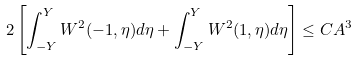<formula> <loc_0><loc_0><loc_500><loc_500>2 \left [ \int _ { - Y } ^ { Y } W ^ { 2 } ( - 1 , \eta ) d \eta + \int _ { - Y } ^ { Y } W ^ { 2 } ( 1 , \eta ) d \eta \right ] \leq C A ^ { 3 }</formula> 